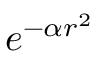Convert formula to latex. <formula><loc_0><loc_0><loc_500><loc_500>e ^ { - \alpha r ^ { 2 } }</formula> 